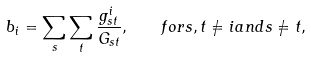Convert formula to latex. <formula><loc_0><loc_0><loc_500><loc_500>b _ { i } = \sum _ { s } \sum _ { t } \frac { g ^ { i } _ { s t } } { G _ { s t } } , \quad f o r { s , t } \neq { i } a n d s \neq { t } ,</formula> 